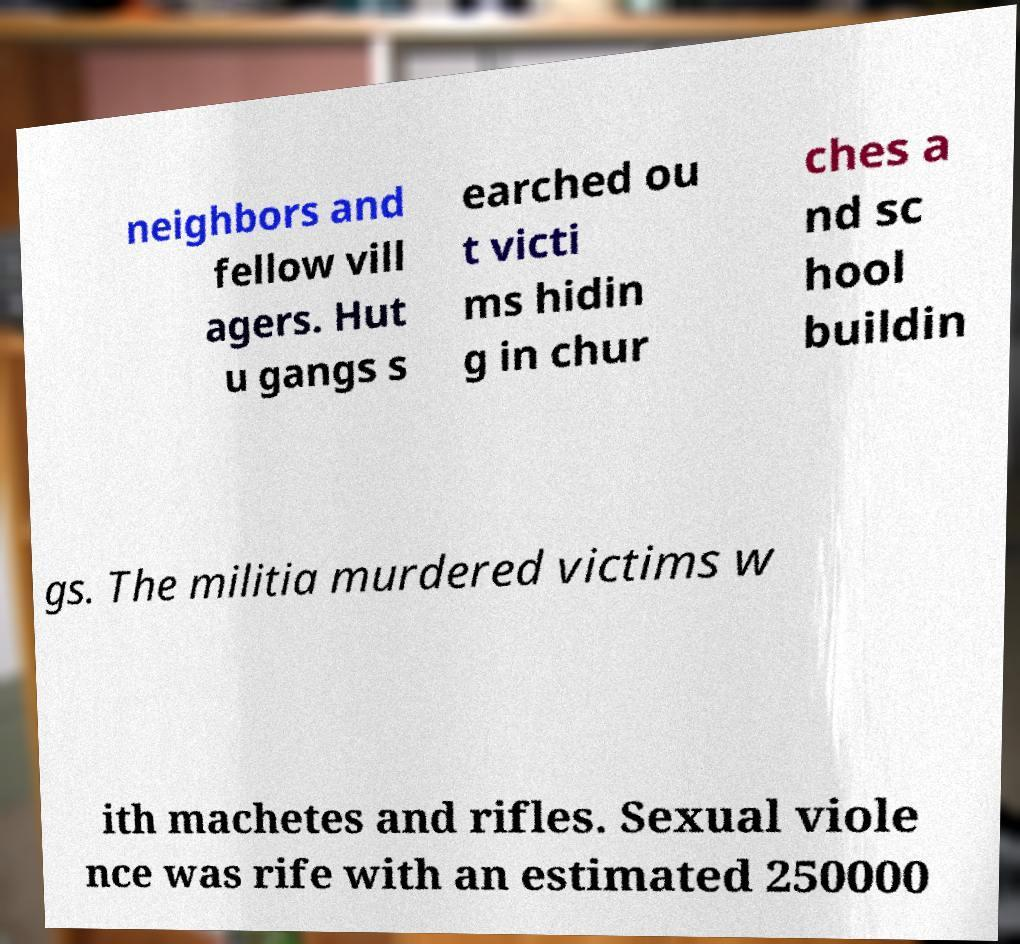For documentation purposes, I need the text within this image transcribed. Could you provide that? neighbors and fellow vill agers. Hut u gangs s earched ou t victi ms hidin g in chur ches a nd sc hool buildin gs. The militia murdered victims w ith machetes and rifles. Sexual viole nce was rife with an estimated 250000 